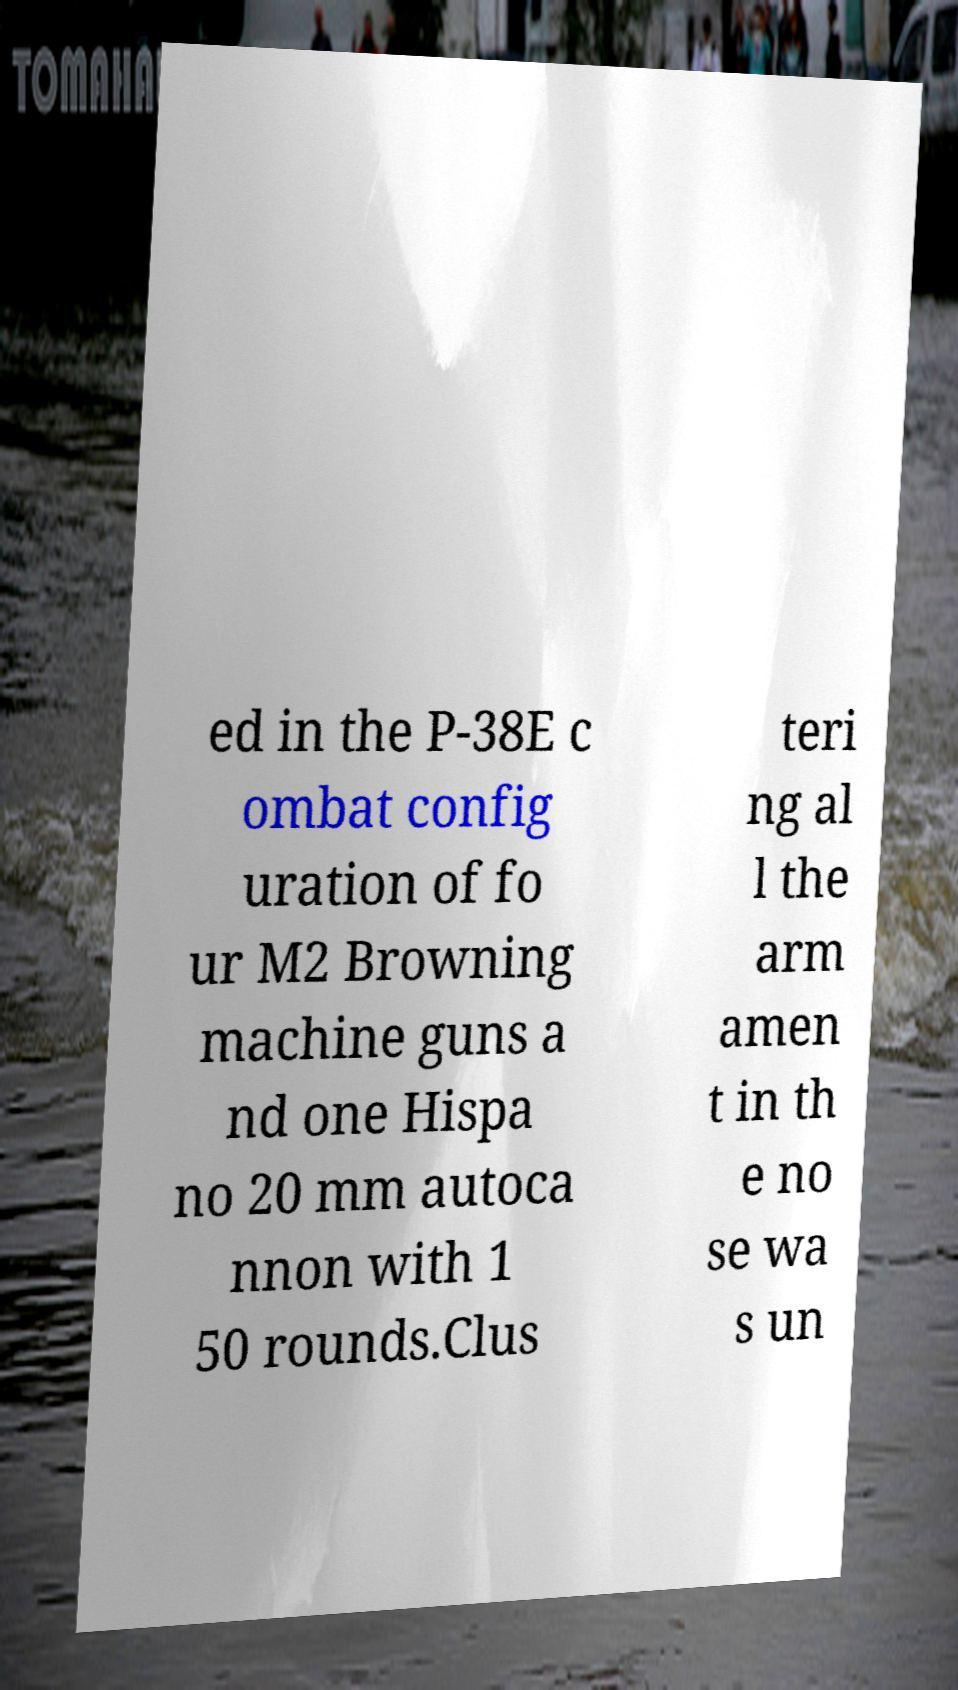Could you extract and type out the text from this image? ed in the P-38E c ombat config uration of fo ur M2 Browning machine guns a nd one Hispa no 20 mm autoca nnon with 1 50 rounds.Clus teri ng al l the arm amen t in th e no se wa s un 